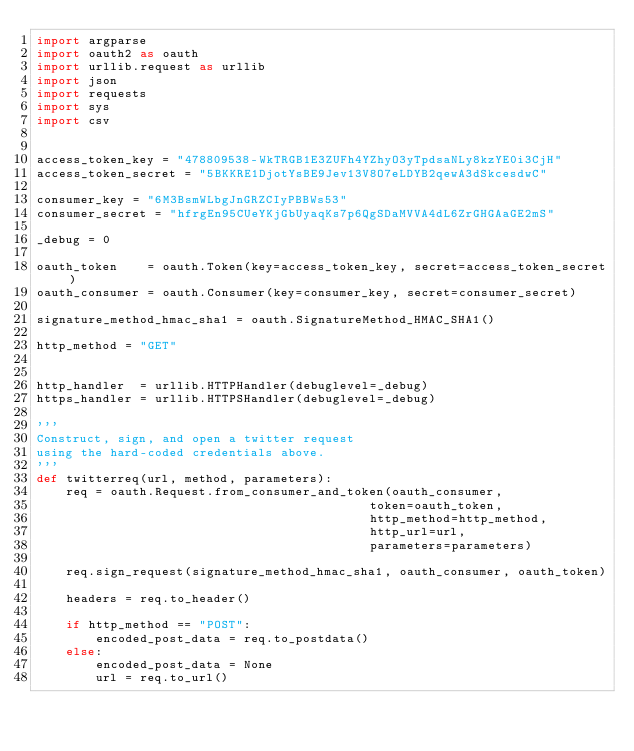Convert code to text. <code><loc_0><loc_0><loc_500><loc_500><_Python_>import argparse
import oauth2 as oauth
import urllib.request as urllib
import json
import requests
import sys
import csv


access_token_key = "478809538-WkTRGB1E3ZUFh4YZhyO3yTpdsaNLy8kzYE0i3CjH"
access_token_secret = "5BKKRE1DjotYsBE9Jev13V8O7eLDYB2qewA3dSkcesdwC"

consumer_key = "6M3BsmWLbgJnGRZCIyPBBWs53"
consumer_secret = "hfrgEn95CUeYKjGbUyaqKs7p6QgSDaMVVA4dL6ZrGHGAaGE2mS"

_debug = 0

oauth_token    = oauth.Token(key=access_token_key, secret=access_token_secret)
oauth_consumer = oauth.Consumer(key=consumer_key, secret=consumer_secret)

signature_method_hmac_sha1 = oauth.SignatureMethod_HMAC_SHA1()

http_method = "GET"


http_handler  = urllib.HTTPHandler(debuglevel=_debug)
https_handler = urllib.HTTPSHandler(debuglevel=_debug)

'''
Construct, sign, and open a twitter request
using the hard-coded credentials above.
'''
def twitterreq(url, method, parameters):
    req = oauth.Request.from_consumer_and_token(oauth_consumer,
                                             token=oauth_token,
                                             http_method=http_method,
                                             http_url=url, 
                                             parameters=parameters)

    req.sign_request(signature_method_hmac_sha1, oauth_consumer, oauth_token)

    headers = req.to_header()

    if http_method == "POST":
        encoded_post_data = req.to_postdata()
    else:
        encoded_post_data = None
        url = req.to_url()
</code> 